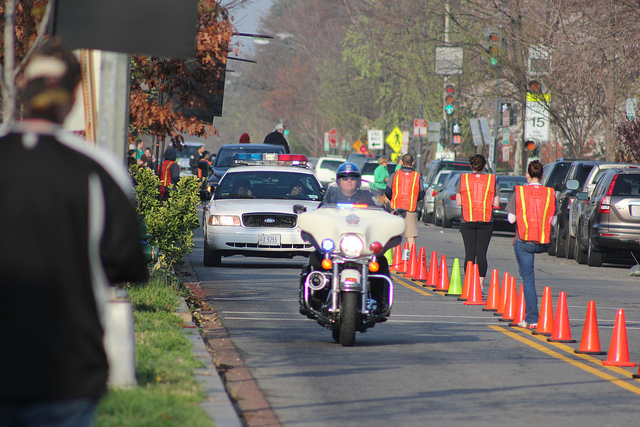How many people are there? In viewing the image, it appears there are at least five visible individuals: a police officer on a motorcycle, three people wearing reflective vests likely directing traffic or managing the event, and a pedestrian on the sidewalk. The nature of the event isn't clear from the image alone, but it seems to be related to traffic control. 